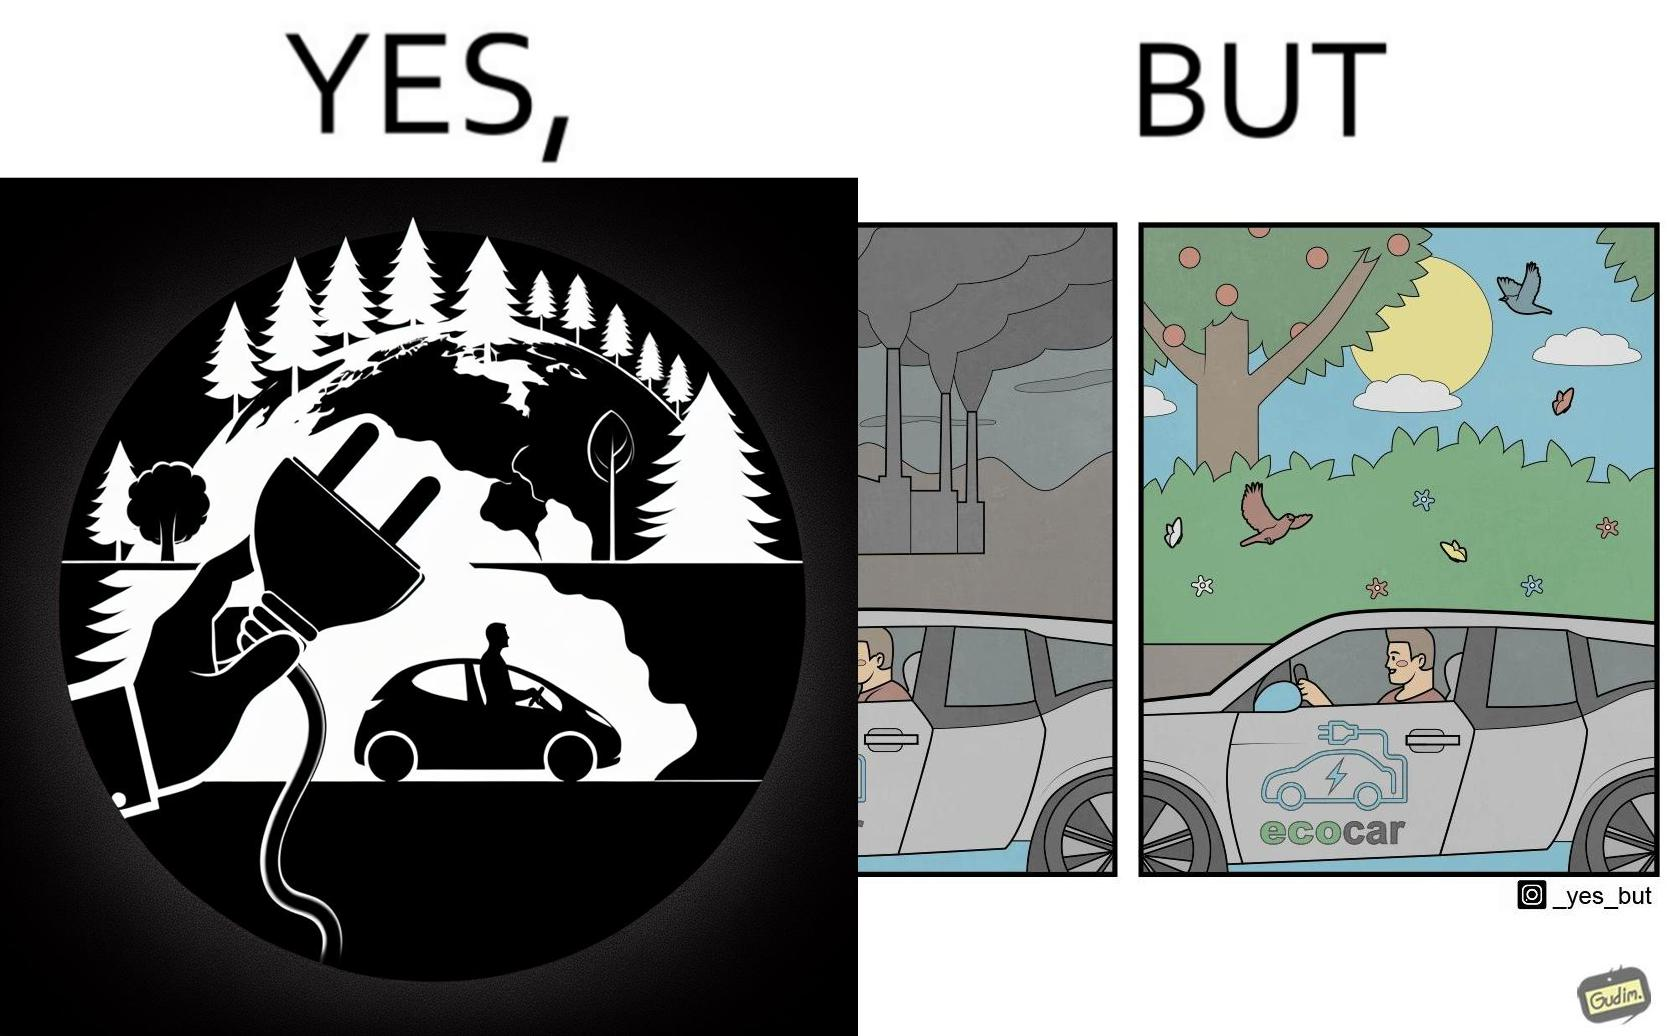Explain the humor or irony in this image. The images are ironic since they show how even though electric powered cars are touted to be a game changer in the automotive industry and claims are made that they will make the world a greener and cleaner place to live in, the reality is quite different. Battery production causes vast amounts of pollution making such claims very doubtful 